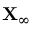Convert formula to latex. <formula><loc_0><loc_0><loc_500><loc_500>X _ { \infty }</formula> 